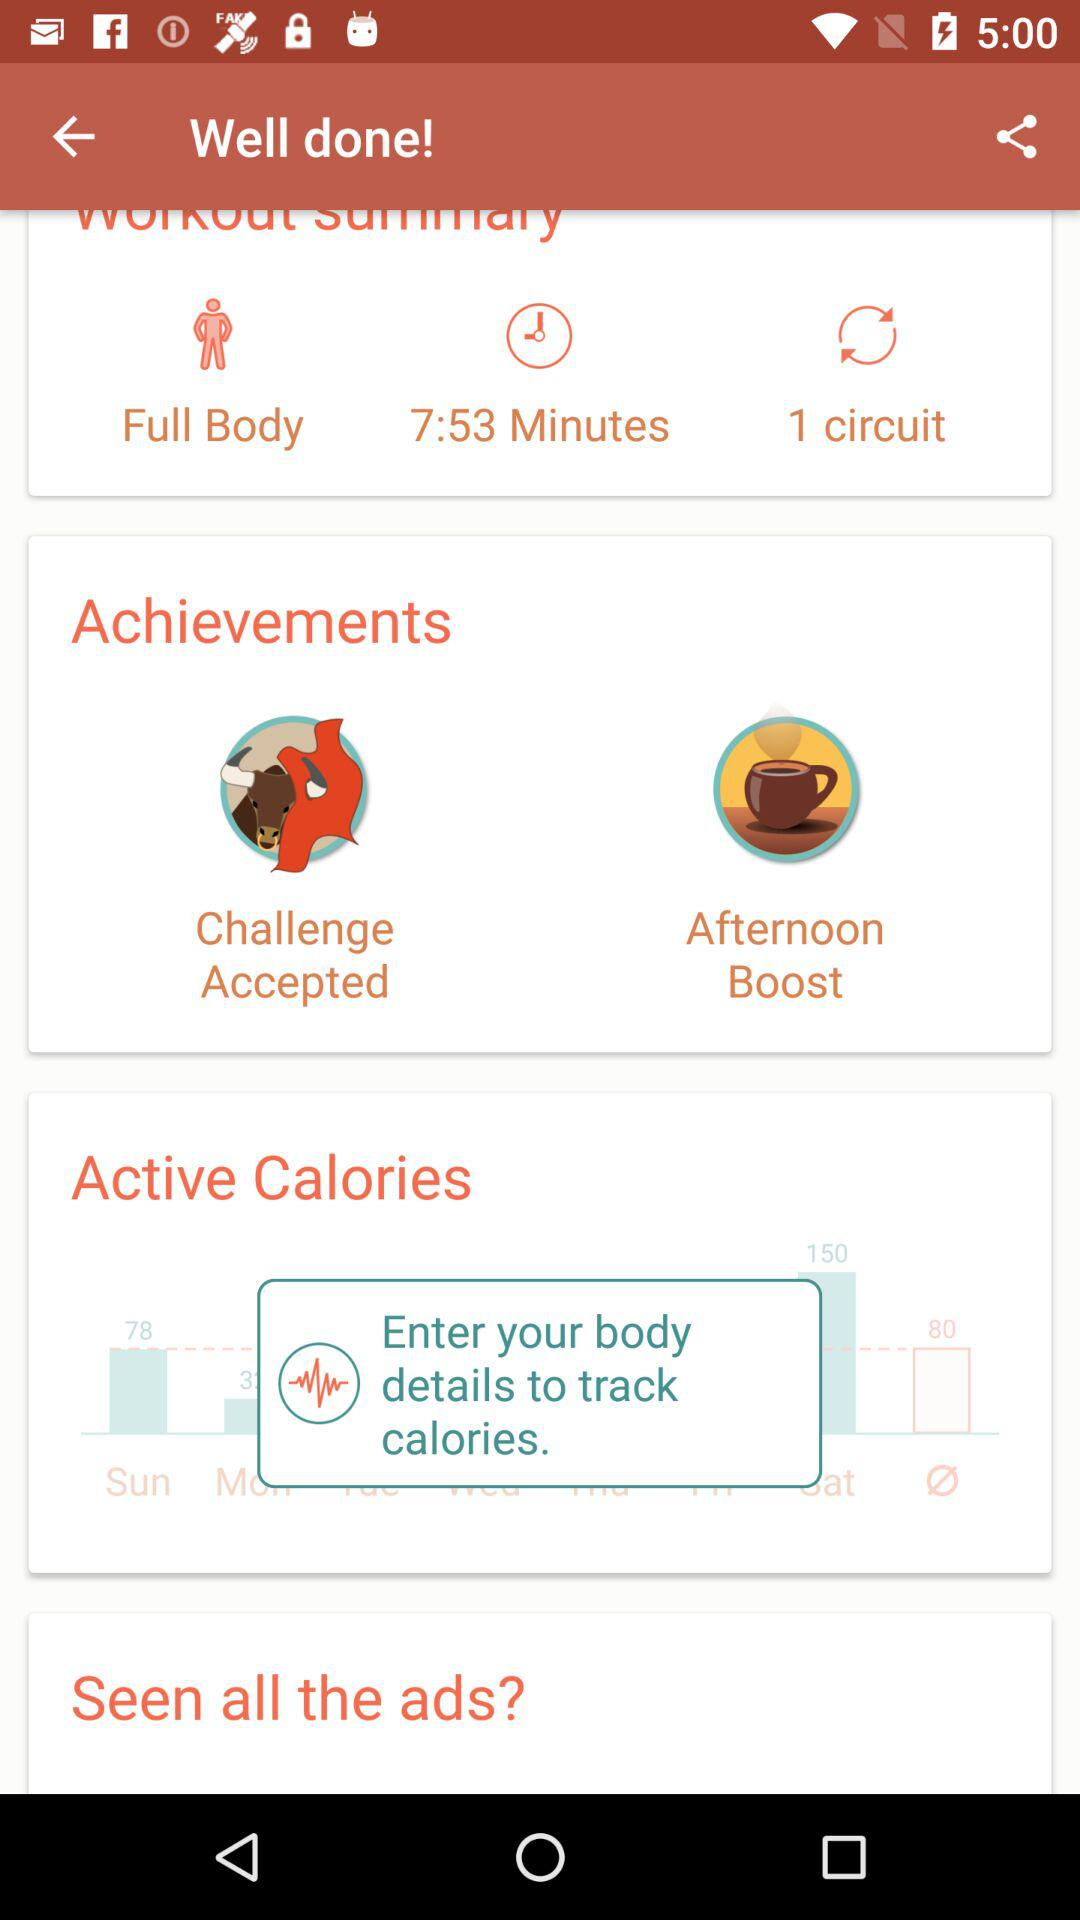What are the achievements? The achievements are "Challenge Accepted" and "Afternoon Boost". 